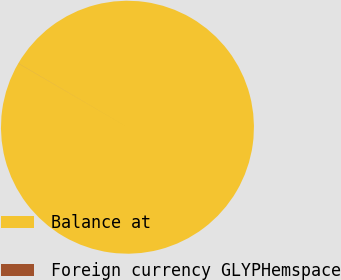Convert chart. <chart><loc_0><loc_0><loc_500><loc_500><pie_chart><fcel>Balance at<fcel>Foreign currency GLYPHemspace<nl><fcel>99.99%<fcel>0.01%<nl></chart> 